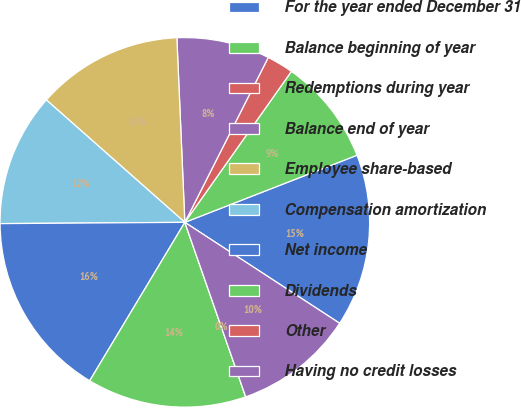Convert chart to OTSL. <chart><loc_0><loc_0><loc_500><loc_500><pie_chart><fcel>For the year ended December 31<fcel>Balance beginning of year<fcel>Redemptions during year<fcel>Balance end of year<fcel>Employee share-based<fcel>Compensation amortization<fcel>Net income<fcel>Dividends<fcel>Other<fcel>Having no credit losses<nl><fcel>15.11%<fcel>9.3%<fcel>2.33%<fcel>8.14%<fcel>12.79%<fcel>11.63%<fcel>16.28%<fcel>13.95%<fcel>0.0%<fcel>10.46%<nl></chart> 